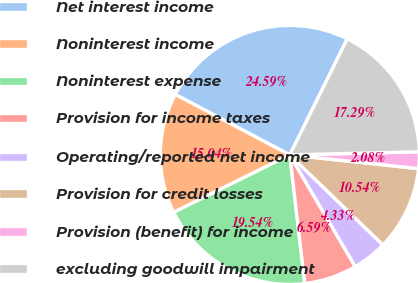Convert chart. <chart><loc_0><loc_0><loc_500><loc_500><pie_chart><fcel>Net interest income<fcel>Noninterest income<fcel>Noninterest expense<fcel>Provision for income taxes<fcel>Operating/reported net income<fcel>Provision for credit losses<fcel>Provision (benefit) for income<fcel>excluding goodwill impairment<nl><fcel>24.59%<fcel>15.04%<fcel>19.54%<fcel>6.59%<fcel>4.33%<fcel>10.54%<fcel>2.08%<fcel>17.29%<nl></chart> 